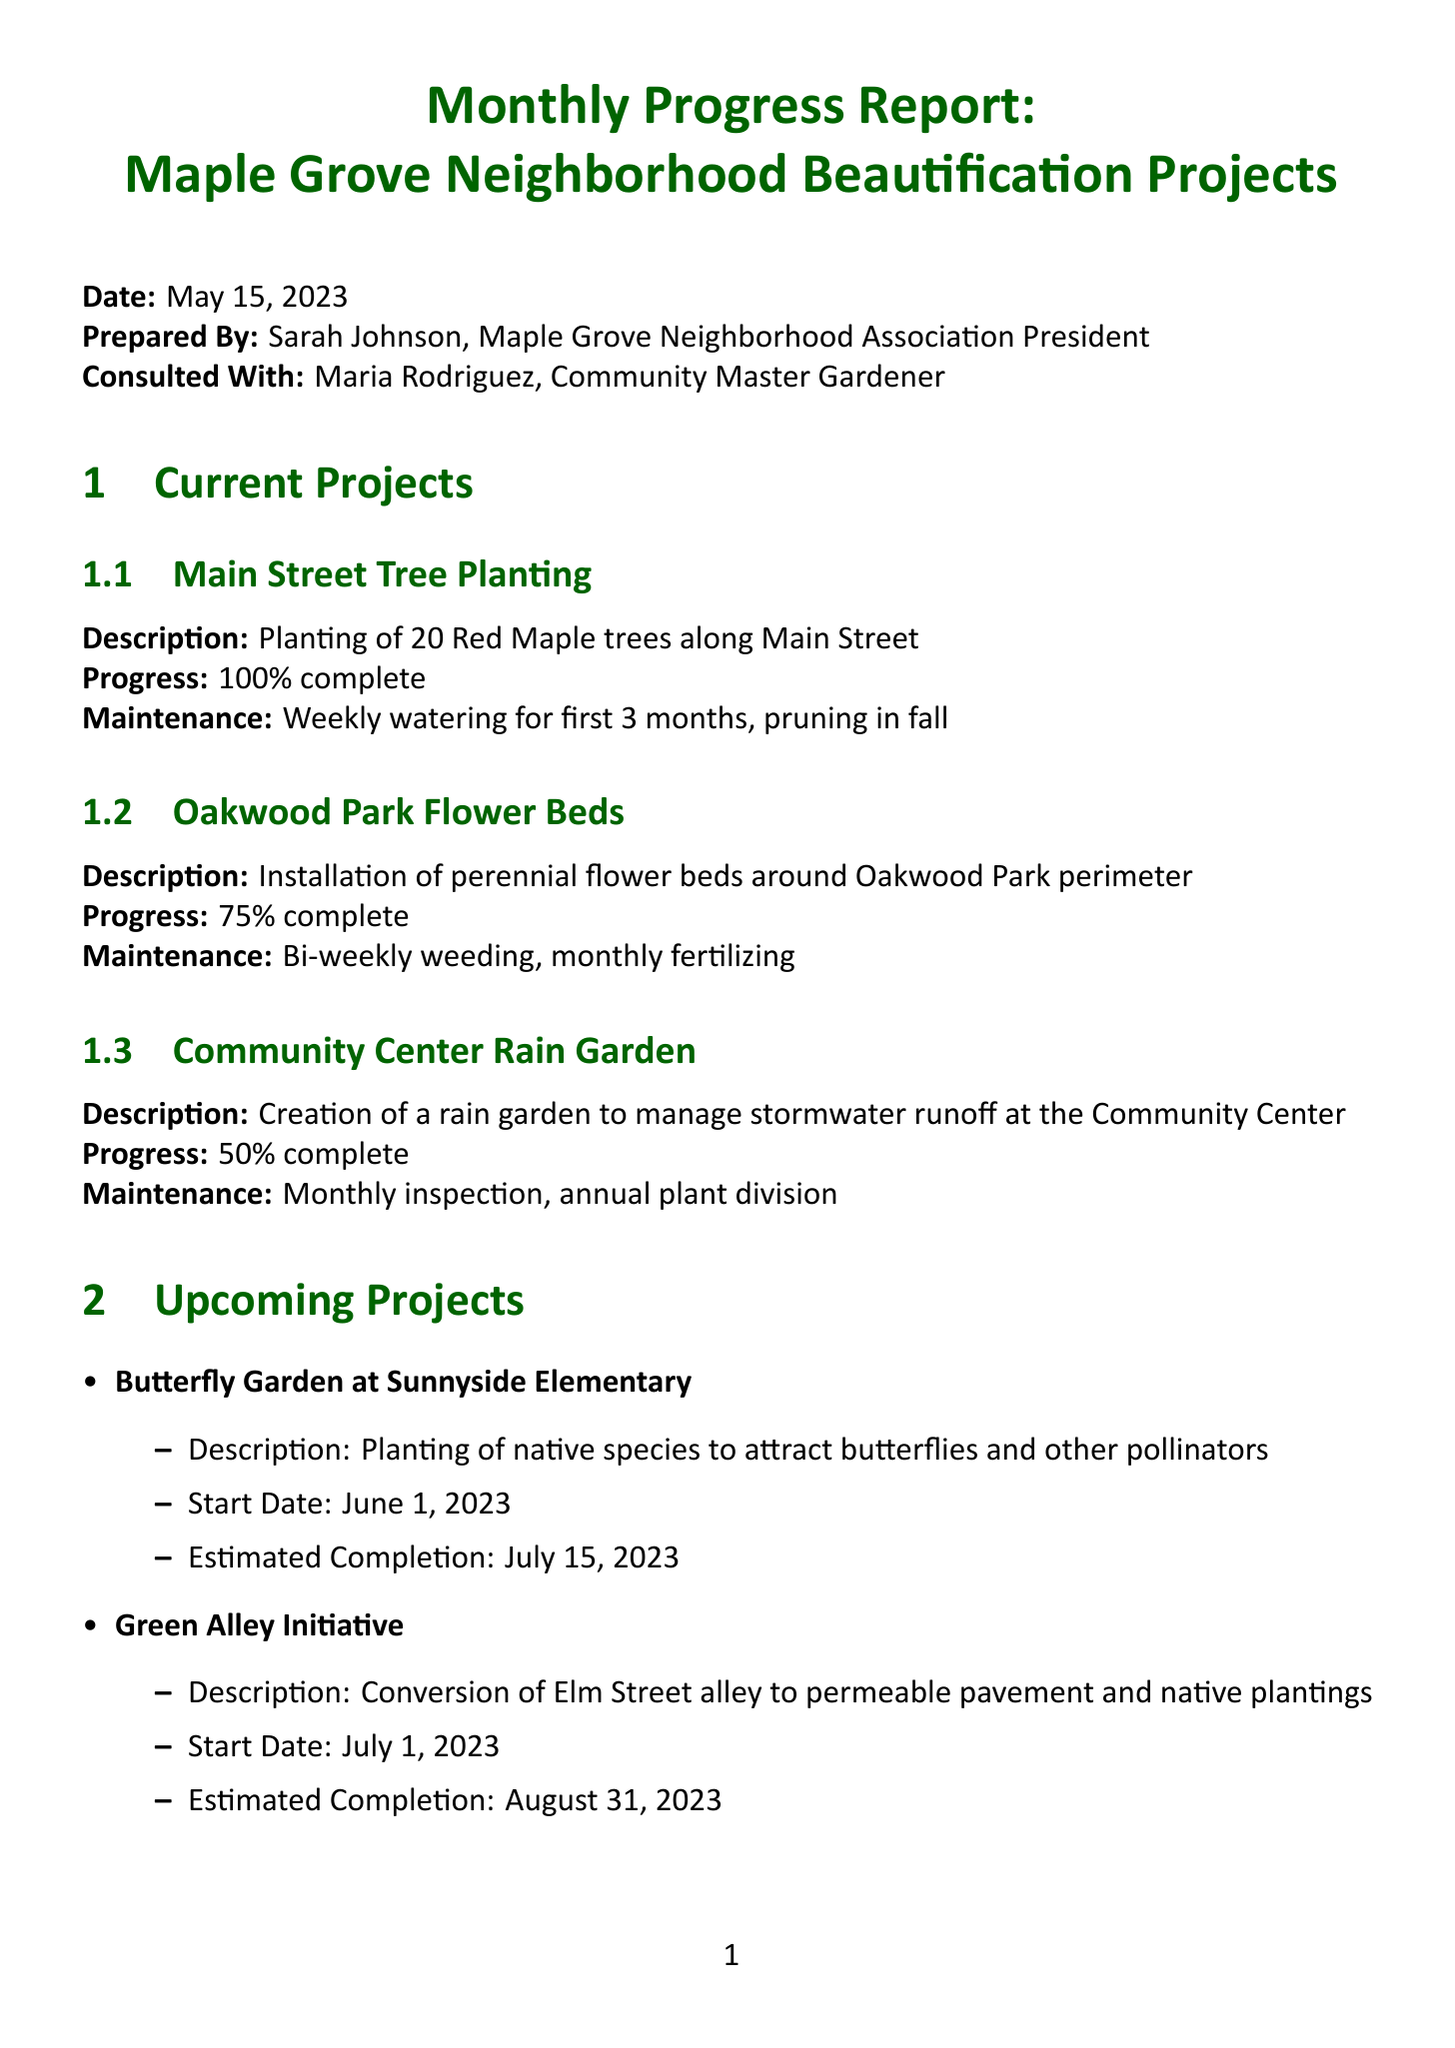What is the report date? The report date is stated in the document as May 15, 2023.
Answer: May 15, 2023 Who prepared the report? The report was prepared by Sarah Johnson, who is the Maple Grove Neighborhood Association President.
Answer: Sarah Johnson What is the completion percentage of the Oakwood Park Flower Beds project? The completion percentage for the Oakwood Park Flower Beds project is specifically stated as 75%.
Answer: 75% What is the estimated completion date for the Butterfly Garden project? The estimated completion date for the Butterfly Garden project is July 15, 2023.
Answer: July 15, 2023 How many total volunteer hours were reported? The total volunteer hours reported in the document sum up to 312 hours.
Answer: 312 What kind of maintenance is scheduled for the Main Street Tree Planting? Maintenance for the Main Street Tree Planting includes weekly watering for the first 3 months and pruning in fall.
Answer: Weekly watering, pruning in fall Who provided guidance on plant selection and care? The guidance on plant selection and care was provided by Maria Rodriguez, the Community Master Gardener.
Answer: Maria Rodriguez What is the total budget allocated for the beautification projects? The total budget allocated for the beautification projects, as noted in the budget summary, is 25,000 dollars.
Answer: 25,000 